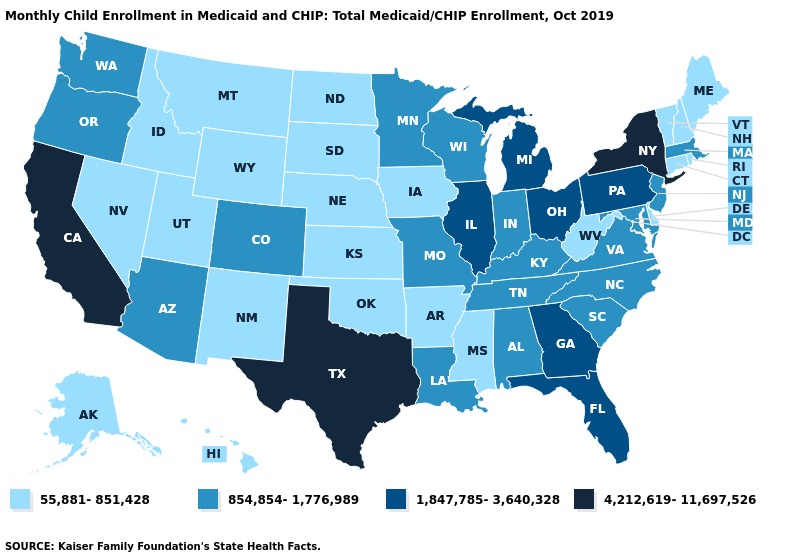What is the lowest value in the West?
Answer briefly. 55,881-851,428. Does Arizona have a higher value than Hawaii?
Write a very short answer. Yes. What is the lowest value in the West?
Concise answer only. 55,881-851,428. What is the value of Maine?
Keep it brief. 55,881-851,428. What is the value of Connecticut?
Write a very short answer. 55,881-851,428. Name the states that have a value in the range 4,212,619-11,697,526?
Keep it brief. California, New York, Texas. What is the lowest value in the USA?
Concise answer only. 55,881-851,428. What is the highest value in states that border Massachusetts?
Be succinct. 4,212,619-11,697,526. What is the lowest value in states that border Montana?
Concise answer only. 55,881-851,428. Does the map have missing data?
Keep it brief. No. Does Arizona have the lowest value in the West?
Write a very short answer. No. Among the states that border Wisconsin , which have the lowest value?
Quick response, please. Iowa. What is the value of Washington?
Short answer required. 854,854-1,776,989. Name the states that have a value in the range 4,212,619-11,697,526?
Write a very short answer. California, New York, Texas. Does Nevada have the highest value in the West?
Write a very short answer. No. 